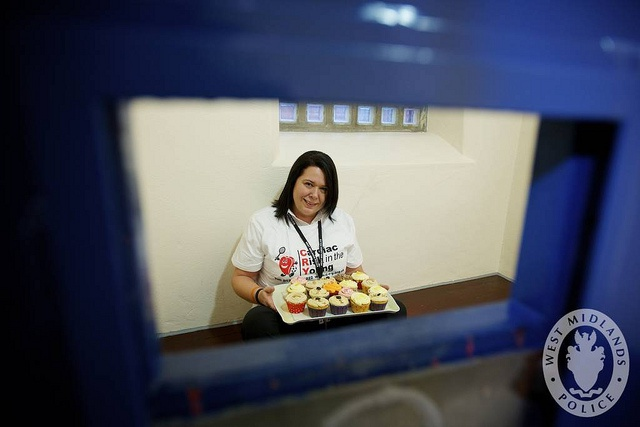Describe the objects in this image and their specific colors. I can see people in black, lightgray, darkgray, and tan tones, cake in black, beige, lightgray, and darkgray tones, cake in black, khaki, and olive tones, cake in black, khaki, brown, and tan tones, and cake in black, khaki, and olive tones in this image. 